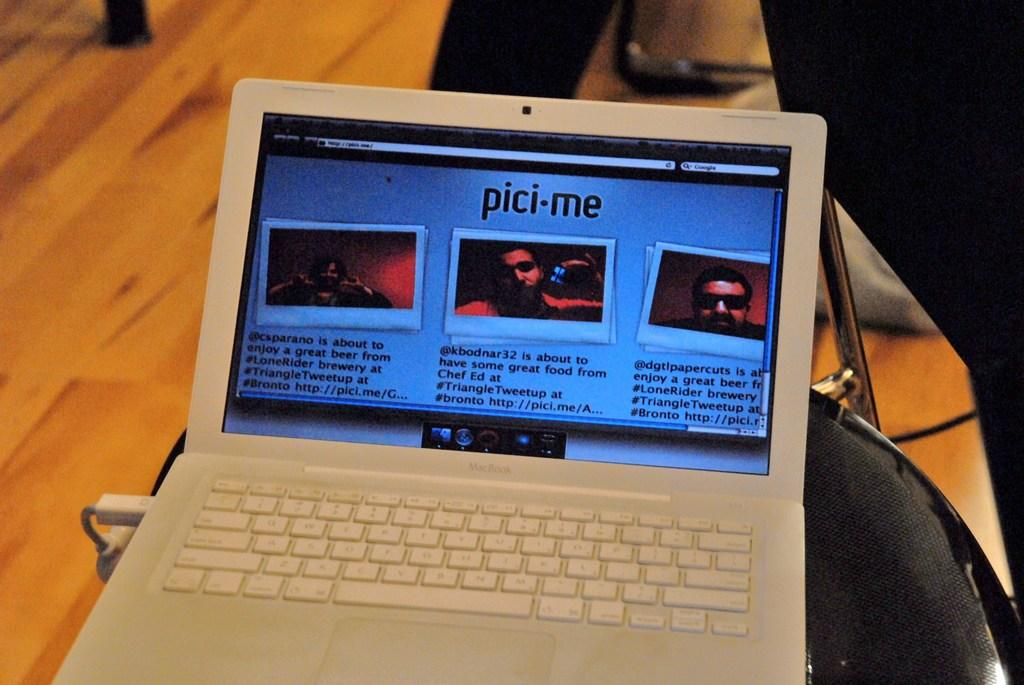What electronic device is present in the image? There is a laptop in the image. Where is the laptop located? The laptop is on a chair. What part of the room can be seen in the image? The floor is visible in the image. What type of garden can be seen through the window in the image? There is no window or garden present in the image; it only features a laptop on a chair and the visible floor. 